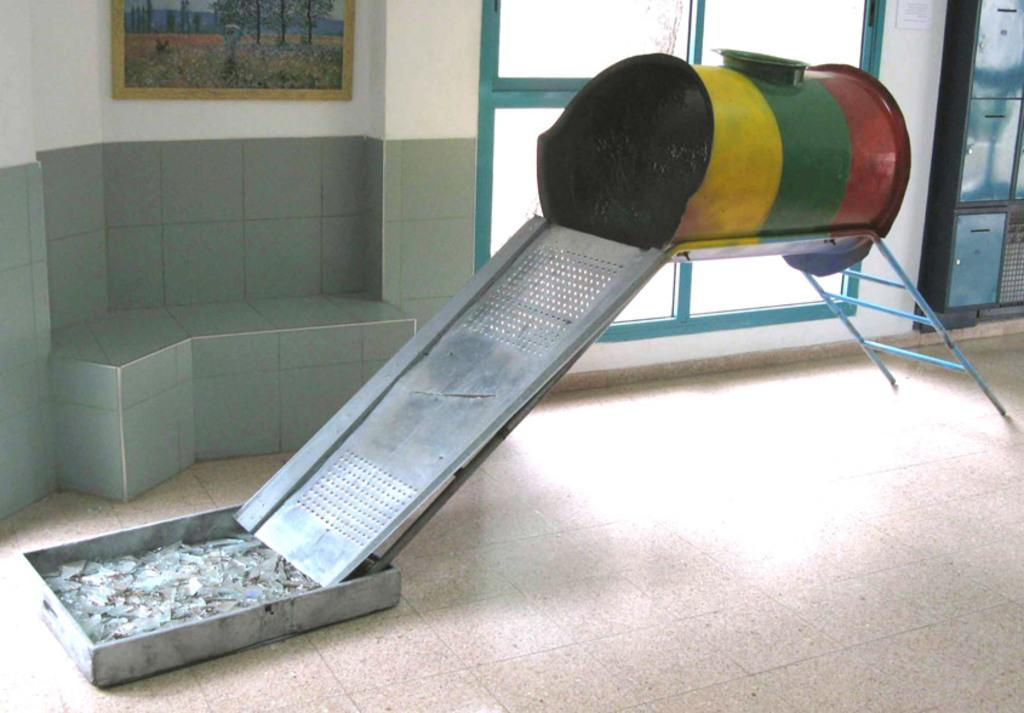What is the main object in the center of the image? There is a slide in the center of the image. Where is the slide located? The slide is on the floor. What can be seen in the background of the image? There are lockers, windows, a photo frame, and a wall in the background of the image. What type of mitten is hanging from the wall in the image? There is no mitten present in the image; the wall in the background has a photo frame, but no mittens are visible. 